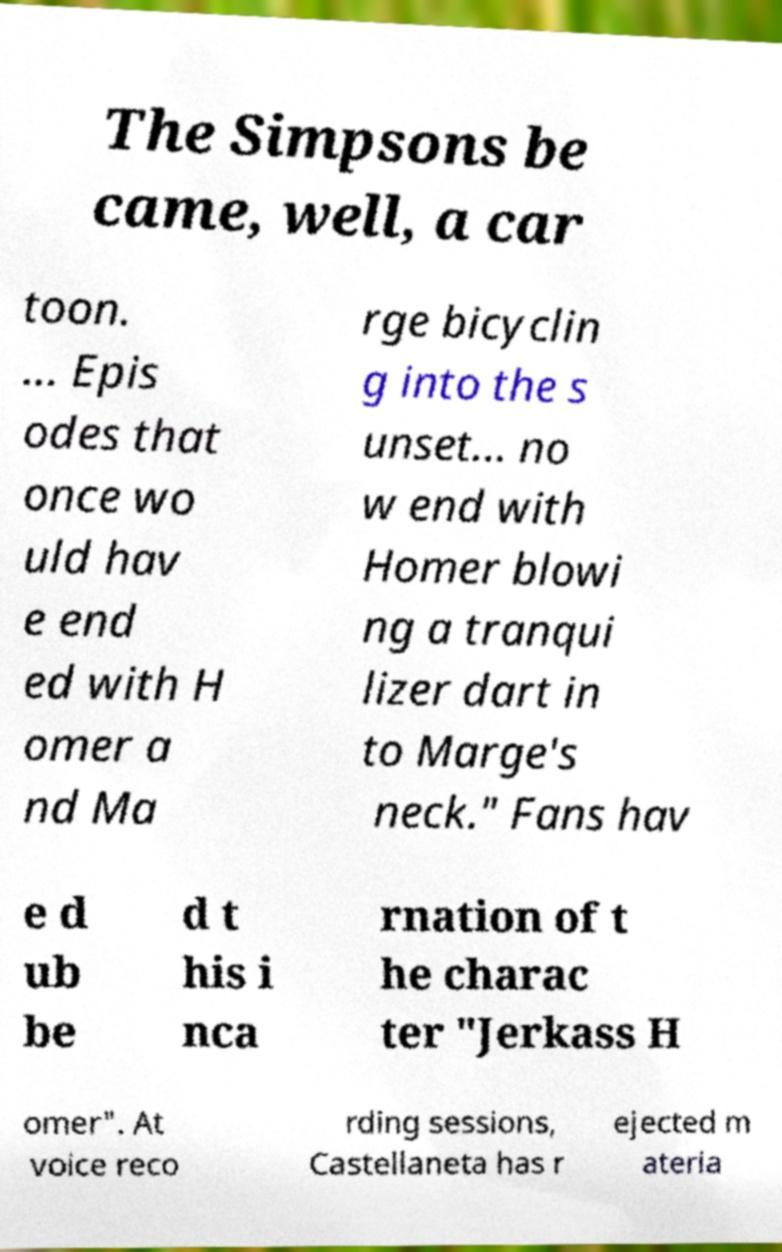Please identify and transcribe the text found in this image. The Simpsons be came, well, a car toon. ... Epis odes that once wo uld hav e end ed with H omer a nd Ma rge bicyclin g into the s unset... no w end with Homer blowi ng a tranqui lizer dart in to Marge's neck." Fans hav e d ub be d t his i nca rnation of t he charac ter "Jerkass H omer". At voice reco rding sessions, Castellaneta has r ejected m ateria 